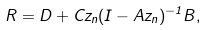Convert formula to latex. <formula><loc_0><loc_0><loc_500><loc_500>R = D + C z _ { n } ( I - A z _ { n } ) ^ { - 1 } B ,</formula> 